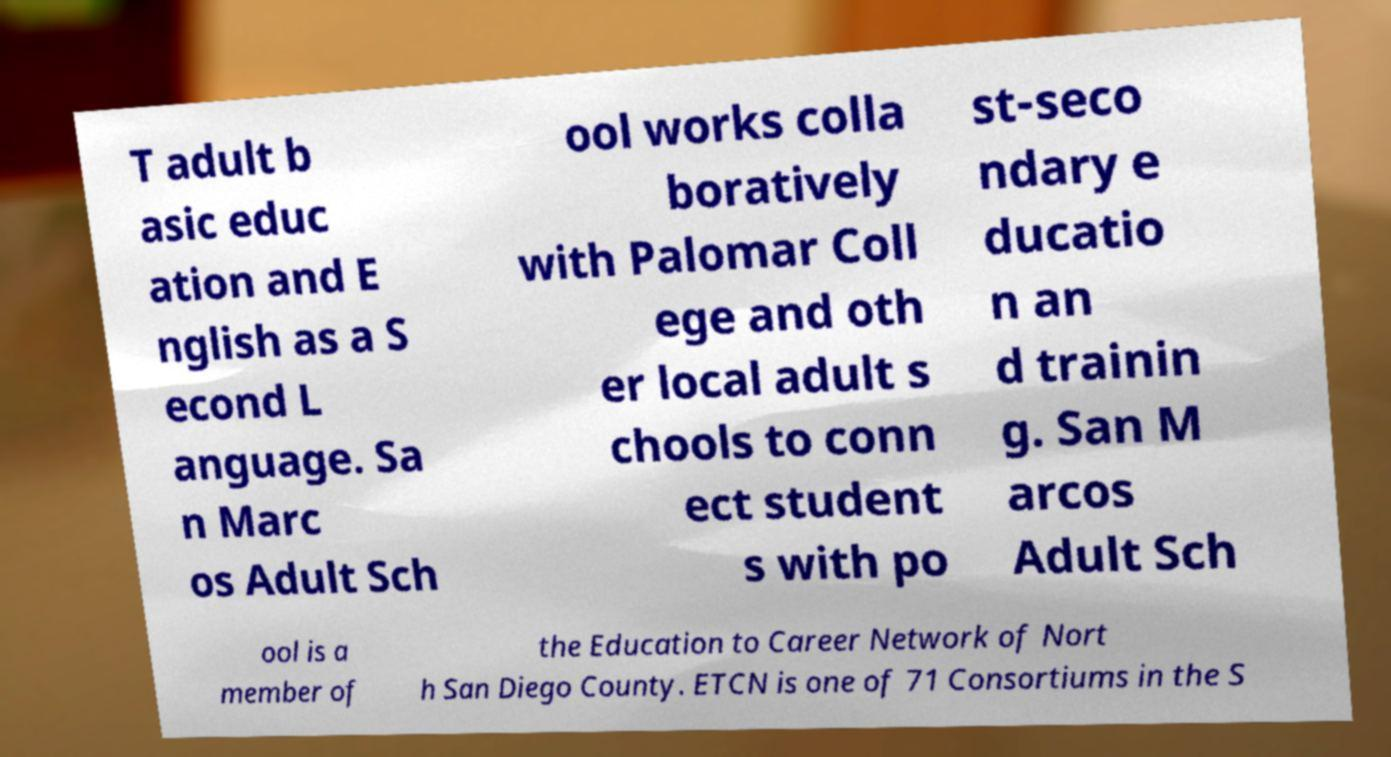Could you extract and type out the text from this image? T adult b asic educ ation and E nglish as a S econd L anguage. Sa n Marc os Adult Sch ool works colla boratively with Palomar Coll ege and oth er local adult s chools to conn ect student s with po st-seco ndary e ducatio n an d trainin g. San M arcos Adult Sch ool is a member of the Education to Career Network of Nort h San Diego County. ETCN is one of 71 Consortiums in the S 